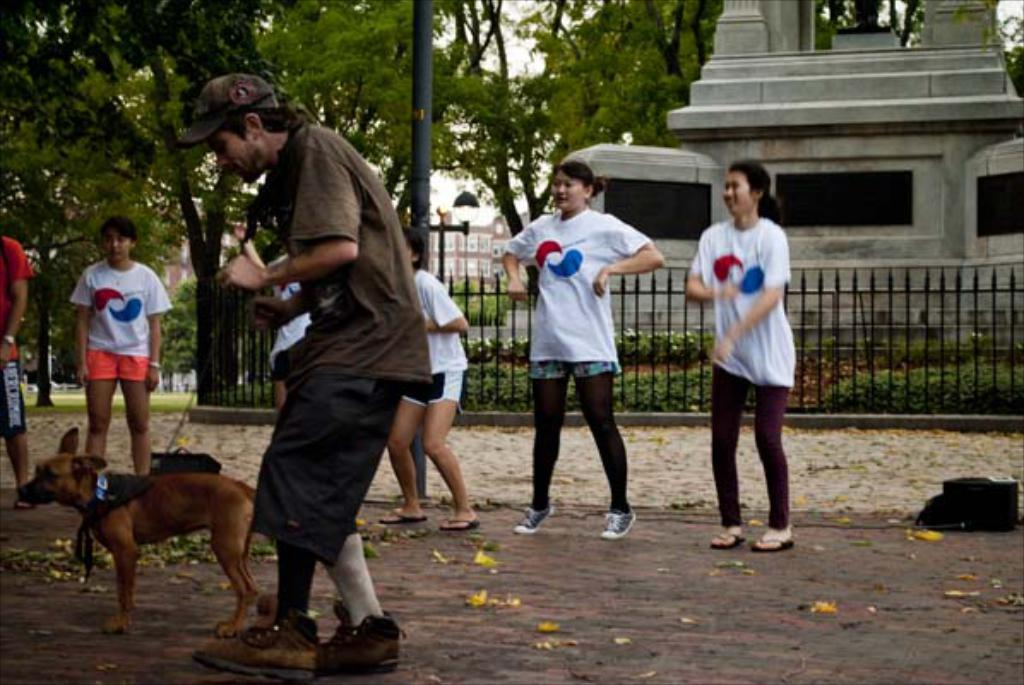What are the people in the image doing? The persons standing on the road are likely walking or waiting. What type of animal is present in the image? There is a dog in the image. What can be seen in the background of the image? Trees, a pole, and a building are visible in the background of the image. What type of barrier is present in the image? There is a fence in the image. Can you describe the kittens exchanging drinks in the image? There are no kittens or drinks being exchanged in the image. 